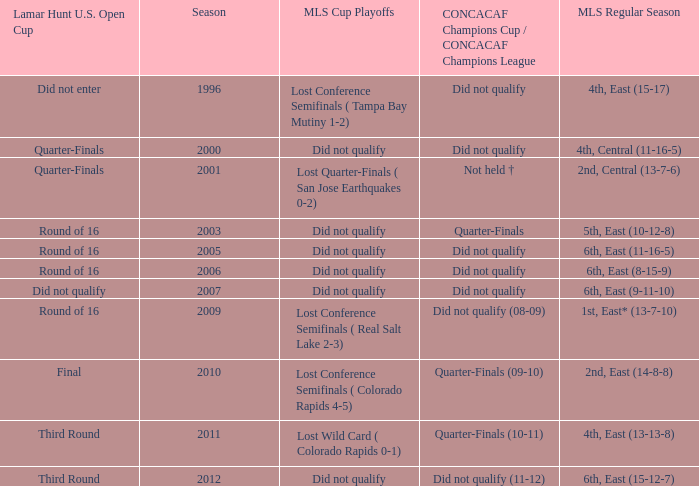What was the lamar hunt u.s. open cup when concacaf champions cup / concacaf champions league was did not qualify and mls regular season was 4th, central (11-16-5)? Quarter-Finals. 